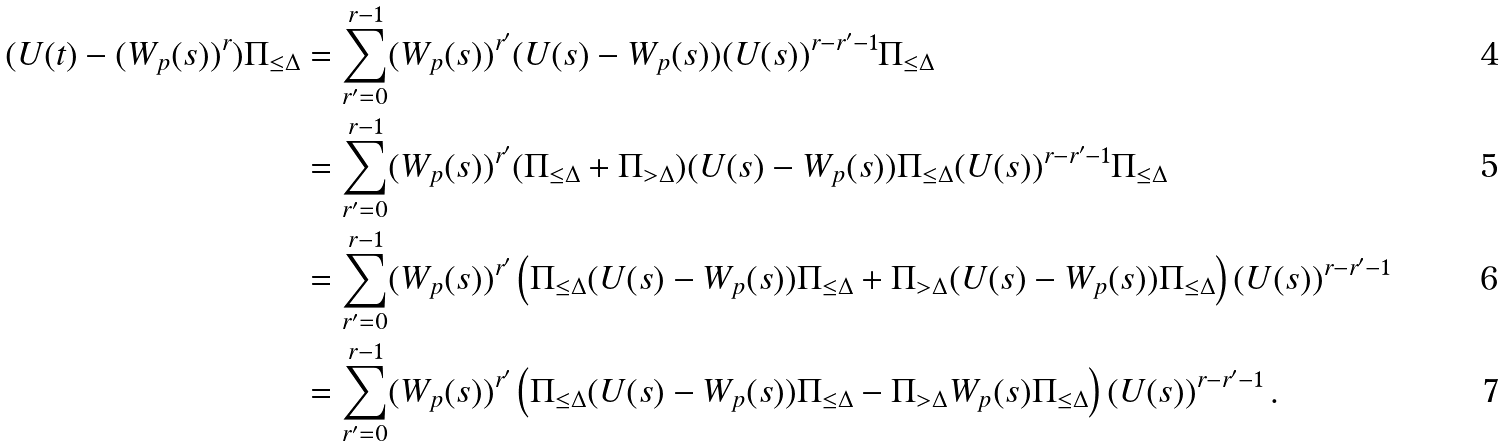Convert formula to latex. <formula><loc_0><loc_0><loc_500><loc_500>( U ( t ) - ( W _ { p } ( s ) ) ^ { r } ) \Pi _ { \leq \Delta } & = \sum ^ { r - 1 } _ { r ^ { \prime } = 0 } ( W _ { p } ( s ) ) ^ { r ^ { \prime } } ( U ( s ) - W _ { p } ( s ) ) ( U ( s ) ) ^ { r - r ^ { \prime } - 1 } \Pi _ { \leq \Delta } \\ & = \sum ^ { r - 1 } _ { r ^ { \prime } = 0 } ( W _ { p } ( s ) ) ^ { r ^ { \prime } } ( \Pi _ { \leq \Delta } + \Pi _ { > \Delta } ) ( U ( s ) - W _ { p } ( s ) ) \Pi _ { \leq \Delta } ( U ( s ) ) ^ { r - r ^ { \prime } - 1 } \Pi _ { \leq \Delta } \\ & = \sum ^ { r - 1 } _ { r ^ { \prime } = 0 } ( W _ { p } ( s ) ) ^ { r ^ { \prime } } \left ( \Pi _ { \leq \Delta } ( U ( s ) - W _ { p } ( s ) ) \Pi _ { \leq \Delta } + \Pi _ { > \Delta } ( U ( s ) - W _ { p } ( s ) ) \Pi _ { \leq \Delta } \right ) ( U ( s ) ) ^ { r - r ^ { \prime } - 1 } \\ & = \sum ^ { r - 1 } _ { r ^ { \prime } = 0 } ( W _ { p } ( s ) ) ^ { r ^ { \prime } } \left ( \Pi _ { \leq \Delta } ( U ( s ) - W _ { p } ( s ) ) \Pi _ { \leq \Delta } - \Pi _ { > \Delta } W _ { p } ( s ) \Pi _ { \leq \Delta } \right ) ( U ( s ) ) ^ { r - r ^ { \prime } - 1 } \, .</formula> 